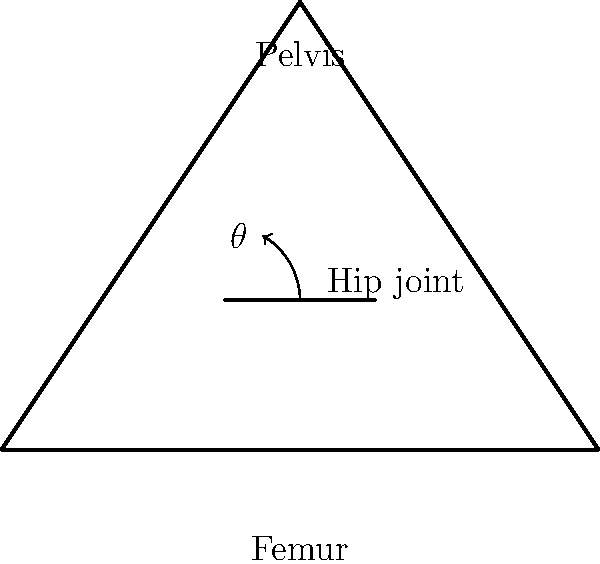In the diagram above, which represents a simplified view of the hip joint, $\theta$ represents the angle of abduction for the femur. What is the typical maximum angle of abduction for a healthy adult dancer's hip joint? To answer this question, we need to consider the following steps:

1. Understand the movement: Hip abduction is the movement of the leg away from the midline of the body in the frontal plane.

2. Normal range of motion: For the general population, the normal range of hip abduction is typically between 30-50 degrees.

3. Dancers' flexibility: Dancers, especially those trained in ballet, often have a greater range of motion due to their extensive training and flexibility exercises.

4. Maximum abduction in dancers: Well-trained dancers can achieve a hip abduction angle of approximately 90 degrees or slightly more.

5. Physiological limits: While some exceptional dancers might exceed 90 degrees, it's important to note that pushing beyond this range can lead to increased risk of injury.

6. Individual variations: The exact maximum angle can vary between individuals based on factors such as age, training history, and anatomical structure.

7. Clinical significance: As a physiotherapist working with aging artists, it's crucial to understand that while a dancer may have achieved extreme ranges of motion in their youth, maintaining such flexibility safely as they age becomes more challenging.

Given these considerations, the typical maximum angle of abduction for a healthy adult dancer's hip joint is around 90 degrees.
Answer: Approximately 90 degrees 